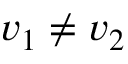Convert formula to latex. <formula><loc_0><loc_0><loc_500><loc_500>v _ { 1 } \ne v _ { 2 }</formula> 